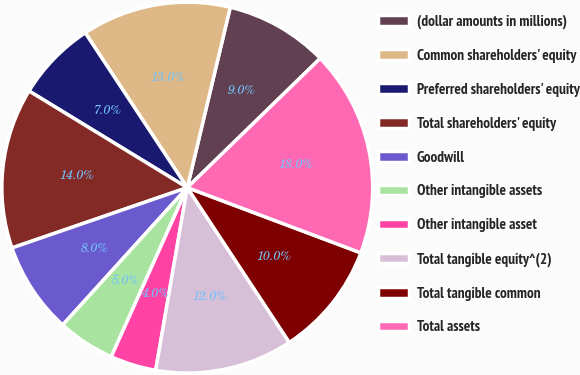Convert chart. <chart><loc_0><loc_0><loc_500><loc_500><pie_chart><fcel>(dollar amounts in millions)<fcel>Common shareholders' equity<fcel>Preferred shareholders' equity<fcel>Total shareholders' equity<fcel>Goodwill<fcel>Other intangible assets<fcel>Other intangible asset<fcel>Total tangible equity^(2)<fcel>Total tangible common<fcel>Total assets<nl><fcel>9.0%<fcel>13.0%<fcel>7.0%<fcel>14.0%<fcel>8.0%<fcel>5.0%<fcel>4.0%<fcel>12.0%<fcel>10.0%<fcel>18.0%<nl></chart> 